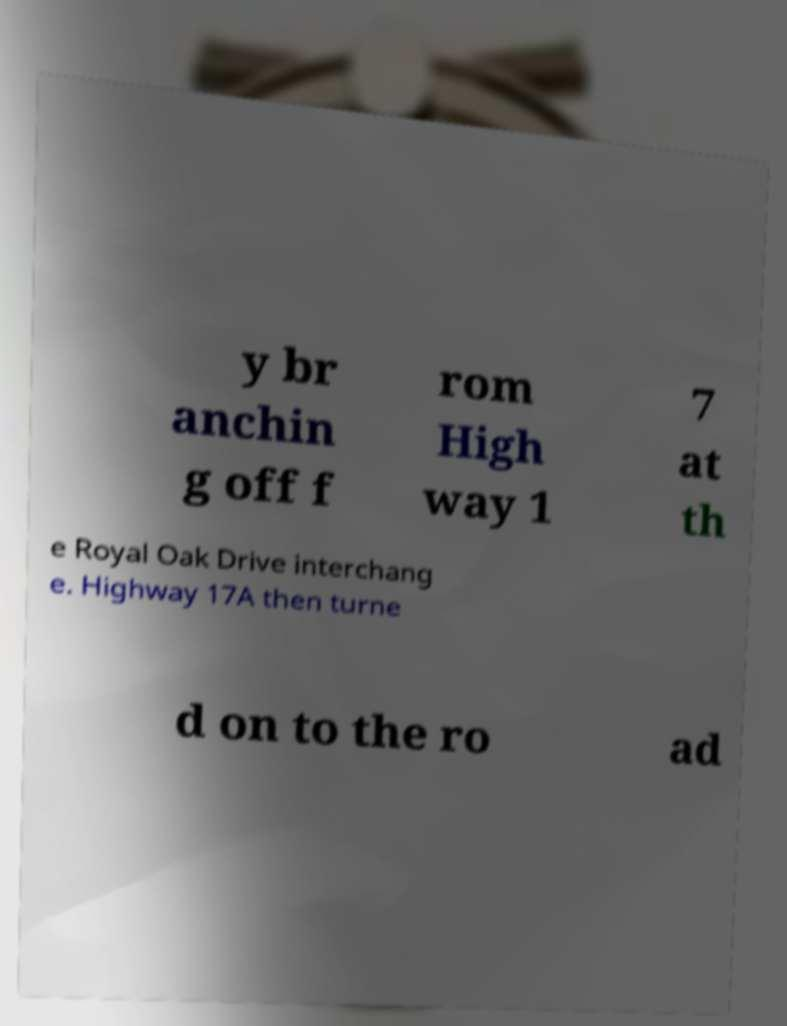What messages or text are displayed in this image? I need them in a readable, typed format. y br anchin g off f rom High way 1 7 at th e Royal Oak Drive interchang e. Highway 17A then turne d on to the ro ad 